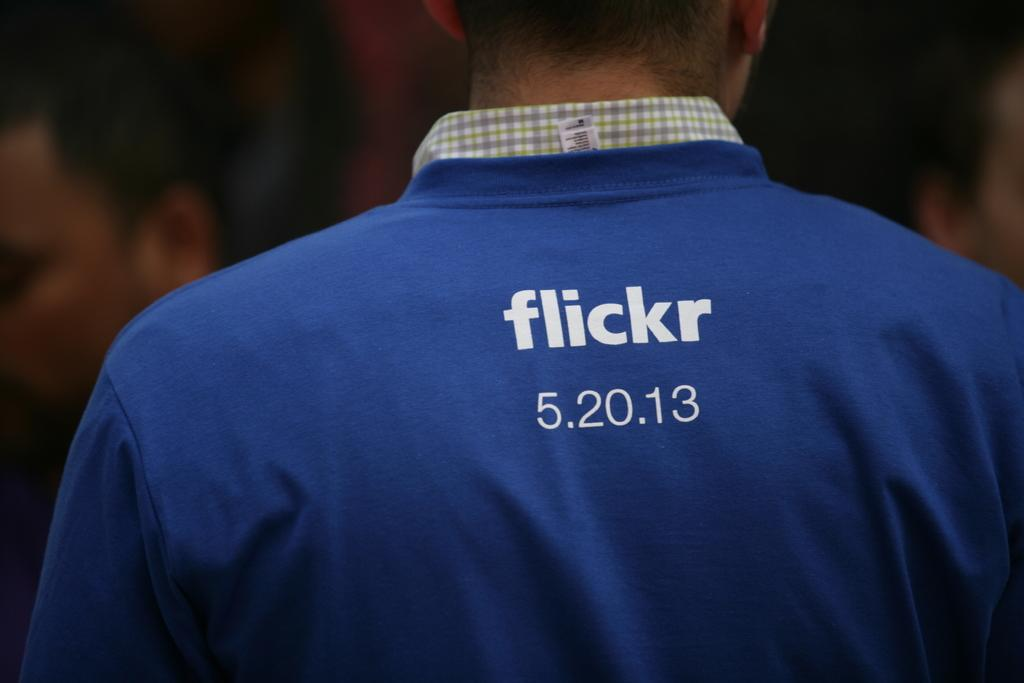How many people are in the image? There are people in the image. What type of shirt is one person wearing? One person is wearing a shirt. What type of shirt is the other person wearing? The other person is wearing a T-shirt. What is printed on the T-shirt? There is text printed on the T-shirt. What type of coal is visible in the image? There is no coal present in the image. Can you read the note that is written on the shirt? There is no note written on the shirt; there is only text printed on the T-shirt. 